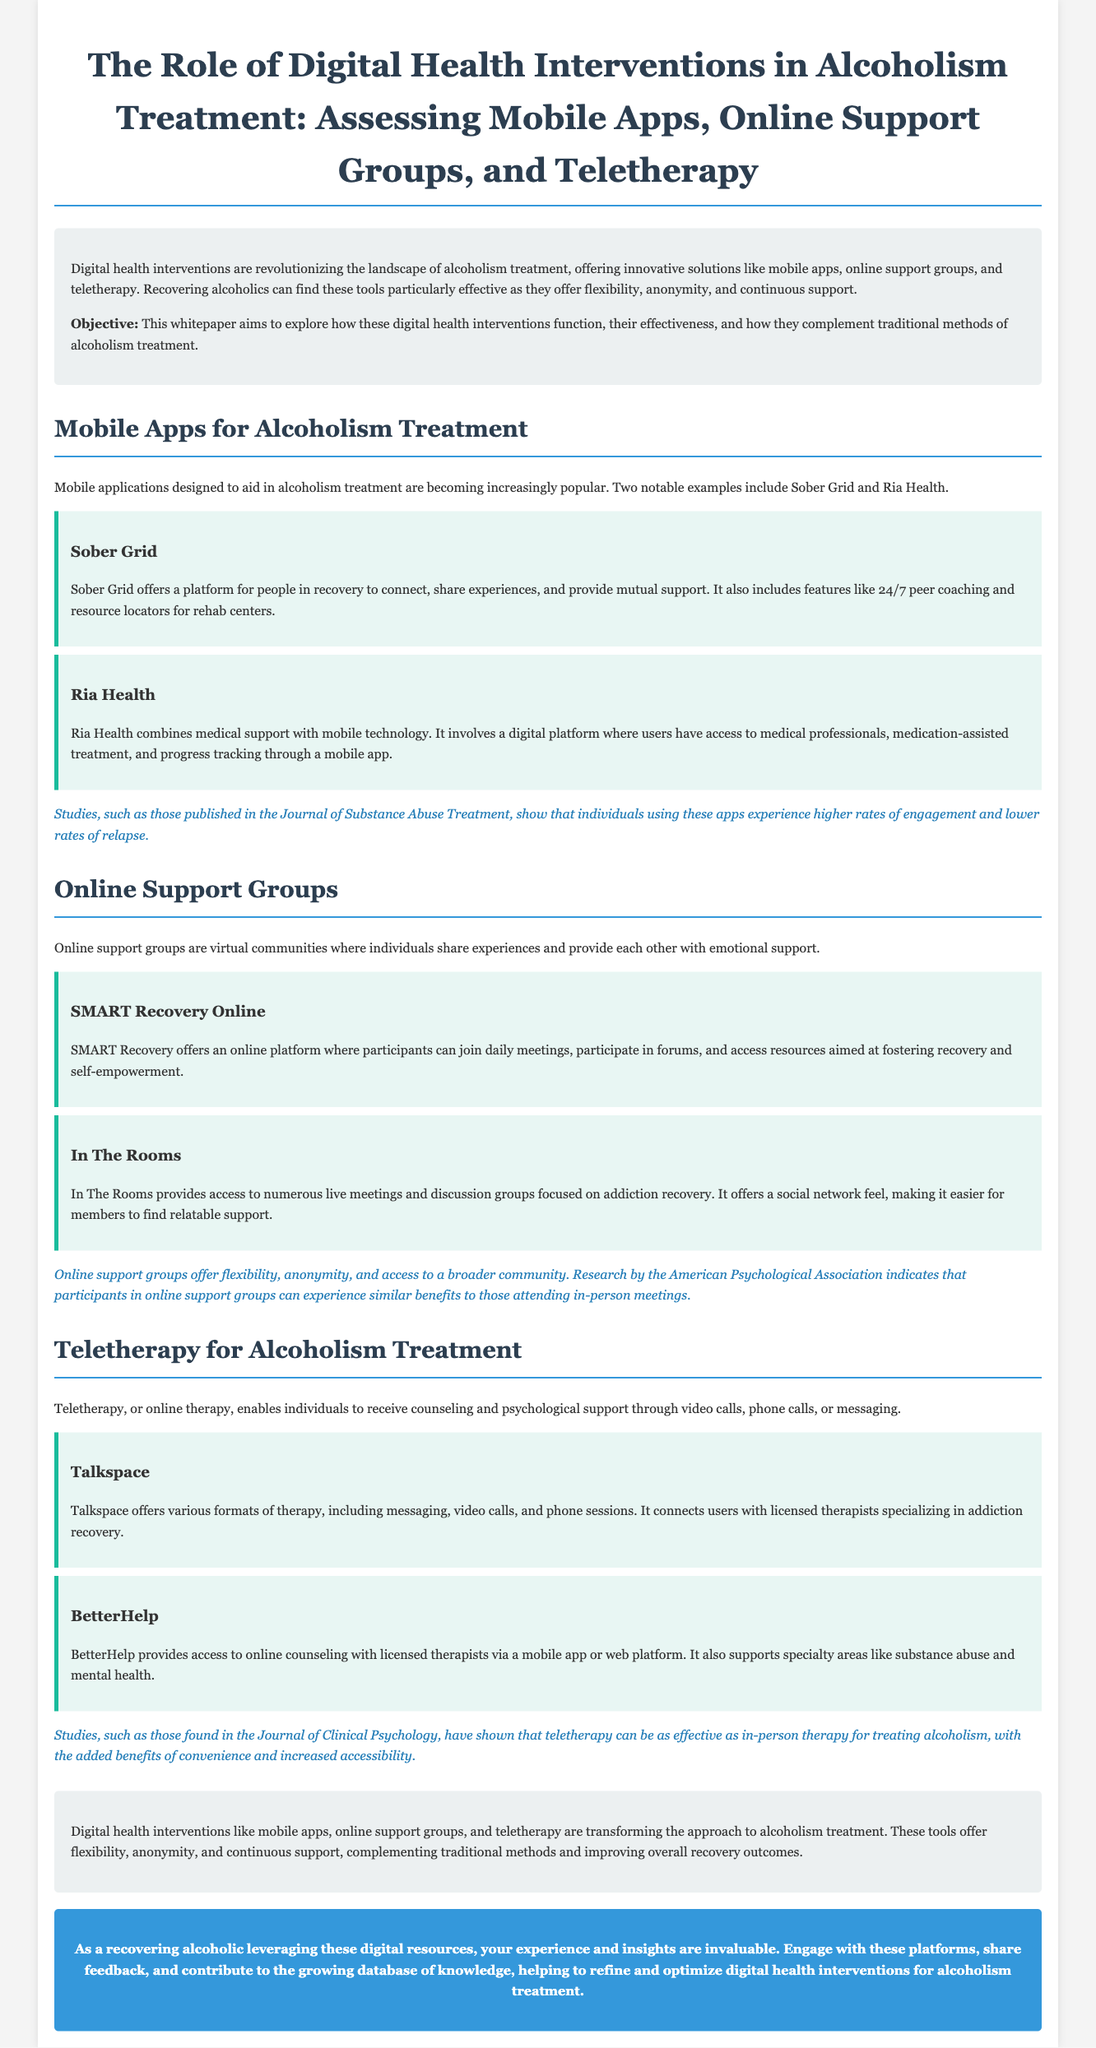What are the three types of digital health interventions discussed? The document lists mobile apps, online support groups, and teletherapy as the three types of digital health interventions in alcoholism treatment.
Answer: mobile apps, online support groups, teletherapy What is the purpose of Sober Grid? Sober Grid offers a platform for people in recovery to connect, share experiences, and provide mutual support.
Answer: connect, share experiences, provide mutual support Which study showed that online support groups offer benefits similar to in-person meetings? The American Psychological Association conducted research indicating that participants in online support groups can experience similar benefits to those attending in-person meetings.
Answer: American Psychological Association What are the two teletherapy platforms mentioned? The document mentions Talkspace and BetterHelp as teletherapy platforms providing support for addiction recovery.
Answer: Talkspace, BetterHelp How does teletherapy impact the treatment of alcoholism according to the document? The Journal of Clinical Psychology states that teletherapy can be as effective as in-person therapy for treating alcoholism.
Answer: as effective as in-person therapy What feature does Ria Health provide? Ria Health combines medical support with mobile technology and provides access to medical professionals, medication-assisted treatment, and progress tracking through a mobile app.
Answer: access to medical professionals, medication-assisted treatment, progress tracking What is the significance of online support groups in alcoholism treatment? Online support groups offer flexibility, anonymity, and access to a broader community for support, as reported in the research.
Answer: flexibility, anonymity, access to a broader community What are the benefits of using mobile apps for alcoholism treatment? Studies show that individuals using these apps experience higher rates of engagement and lower rates of relapse.
Answer: higher rates of engagement, lower rates of relapse 